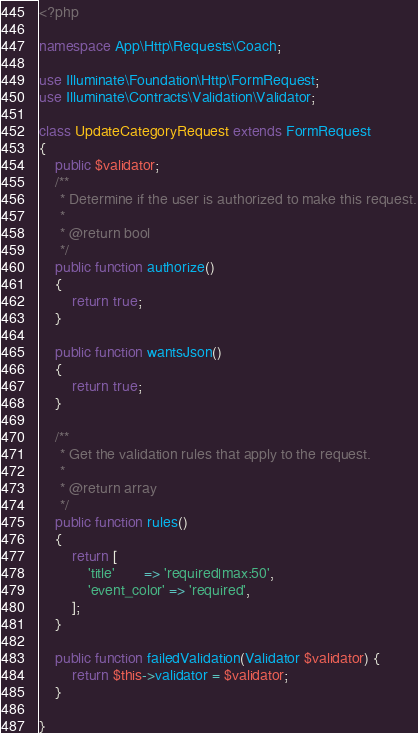<code> <loc_0><loc_0><loc_500><loc_500><_PHP_><?php

namespace App\Http\Requests\Coach;

use Illuminate\Foundation\Http\FormRequest;
use Illuminate\Contracts\Validation\Validator;

class UpdateCategoryRequest extends FormRequest
{
    public $validator; 
    /**
     * Determine if the user is authorized to make this request.
     *
     * @return bool
     */
    public function authorize()
    {
        return true;
    }

    public function wantsJson()
    {
        return true;
    }

    /**
     * Get the validation rules that apply to the request.
     *
     * @return array
     */
    public function rules()
    {
        return [
            'title'       => 'required|max:50',
            'event_color' => 'required',
        ];
    }

    public function failedValidation(Validator $validator) { 
        return $this->validator = $validator;
    }

}
</code> 